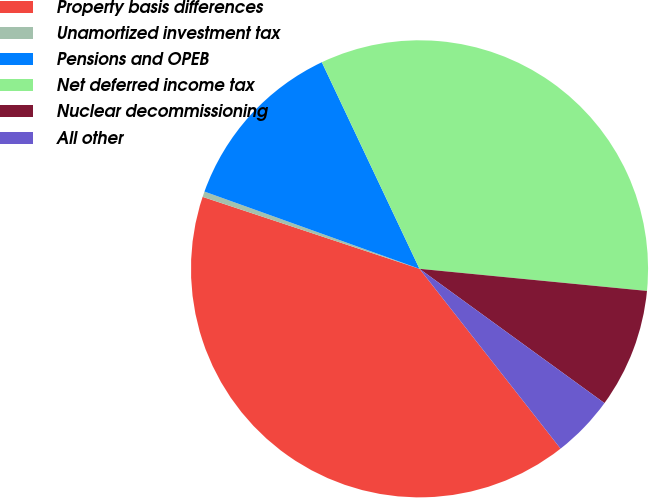Convert chart to OTSL. <chart><loc_0><loc_0><loc_500><loc_500><pie_chart><fcel>Property basis differences<fcel>Unamortized investment tax<fcel>Pensions and OPEB<fcel>Net deferred income tax<fcel>Nuclear decommissioning<fcel>All other<nl><fcel>40.68%<fcel>0.39%<fcel>12.48%<fcel>33.57%<fcel>8.45%<fcel>4.42%<nl></chart> 